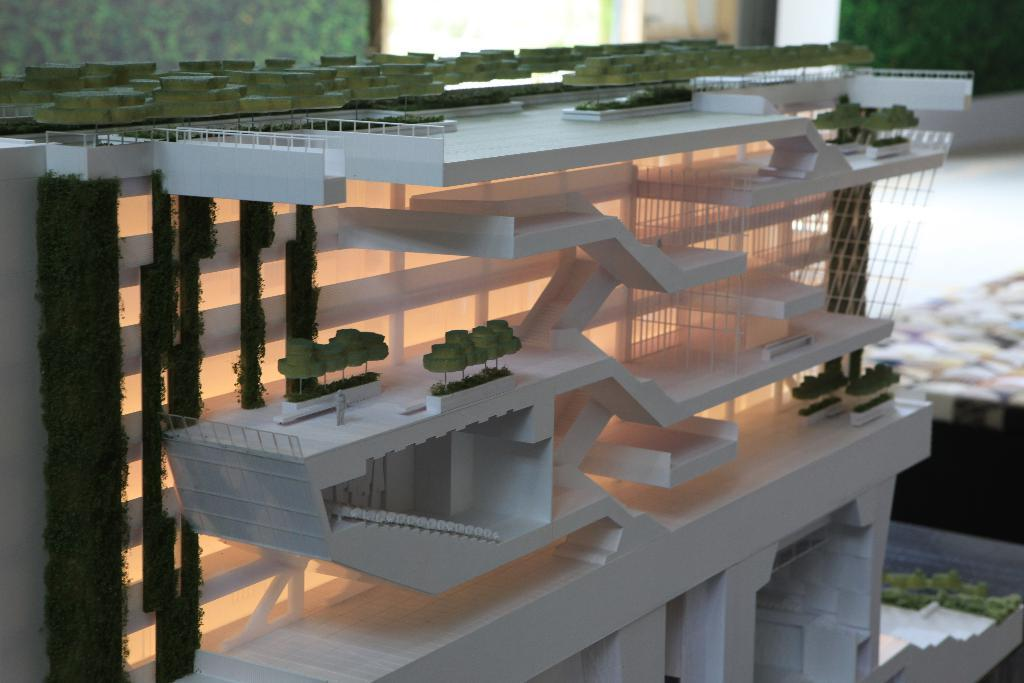What is the main subject of the image? The main subject of the image is a project of a building on a table. What can be seen in the project of the building? Walls are visible in the image. What type of trousers are being worn by the building in the image? There are no trousers present in the image, as it features a project of a building on a table. 